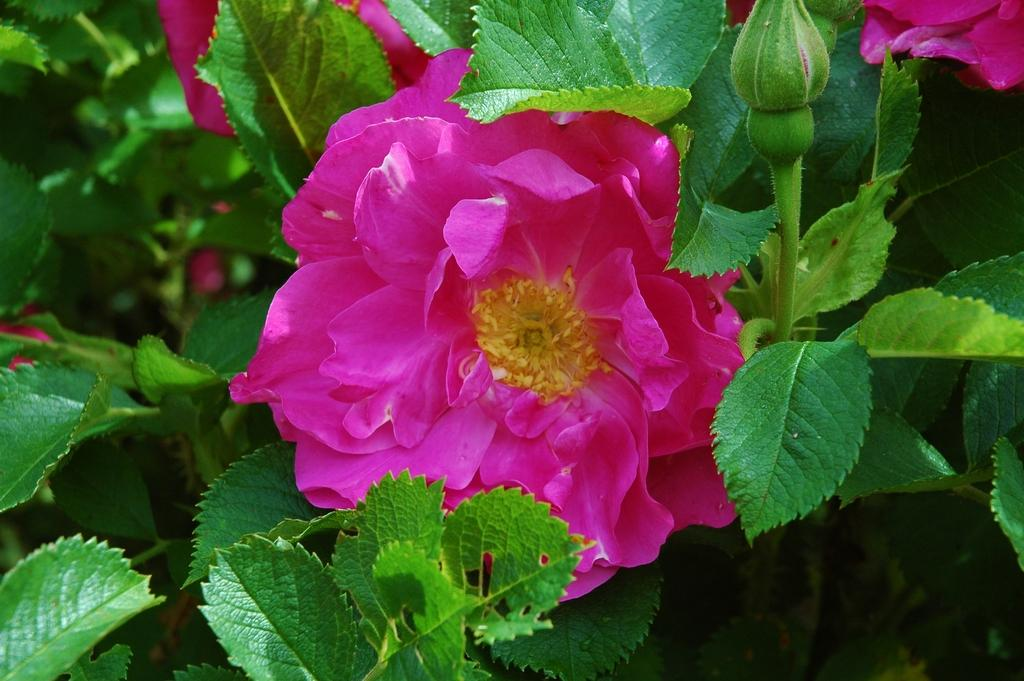What type of flower is present in the image? There is a pink color flower in the image. Can you describe the flower bud in the image? There is a flower bud on the top right side of the image. What can be seen in the background of the image? There are plants in the background of the image. What type of heart-shaped object can be seen near the flower in the image? There is no heart-shaped object present near the flower in the image. Can you describe the edge of the flower in the image? The edge of the flower cannot be described in detail, as the image does not provide enough information about the flower's shape or structure. 